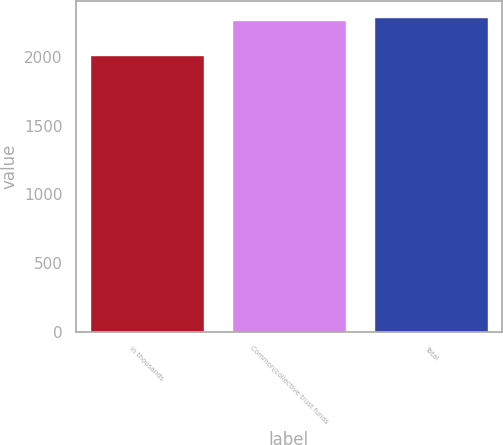Convert chart to OTSL. <chart><loc_0><loc_0><loc_500><loc_500><bar_chart><fcel>in thousands<fcel>Common/collective trust funds<fcel>Total<nl><fcel>2012<fcel>2265<fcel>2290.3<nl></chart> 